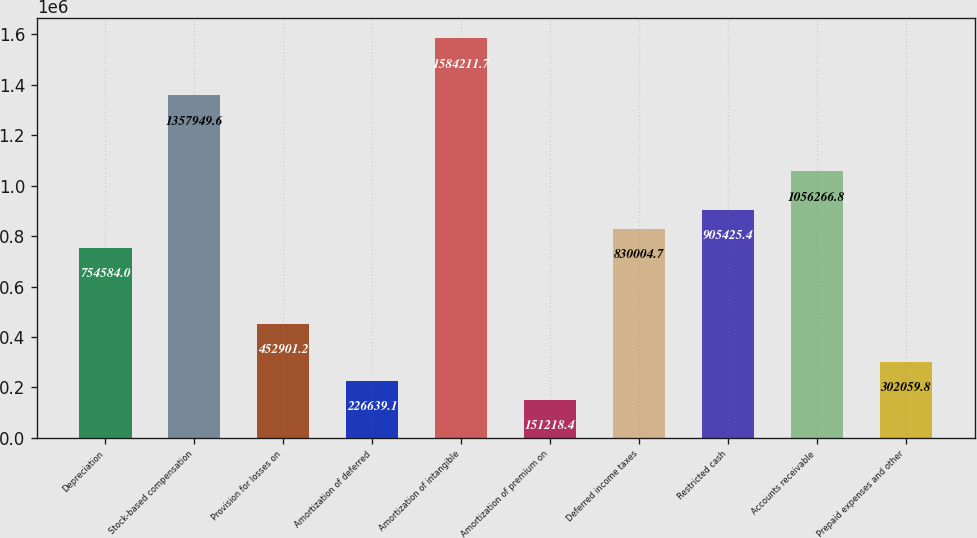<chart> <loc_0><loc_0><loc_500><loc_500><bar_chart><fcel>Depreciation<fcel>Stock-based compensation<fcel>Provision for losses on<fcel>Amortization of deferred<fcel>Amortization of intangible<fcel>Amortization of premium on<fcel>Deferred income taxes<fcel>Restricted cash<fcel>Accounts receivable<fcel>Prepaid expenses and other<nl><fcel>754584<fcel>1.35795e+06<fcel>452901<fcel>226639<fcel>1.58421e+06<fcel>151218<fcel>830005<fcel>905425<fcel>1.05627e+06<fcel>302060<nl></chart> 